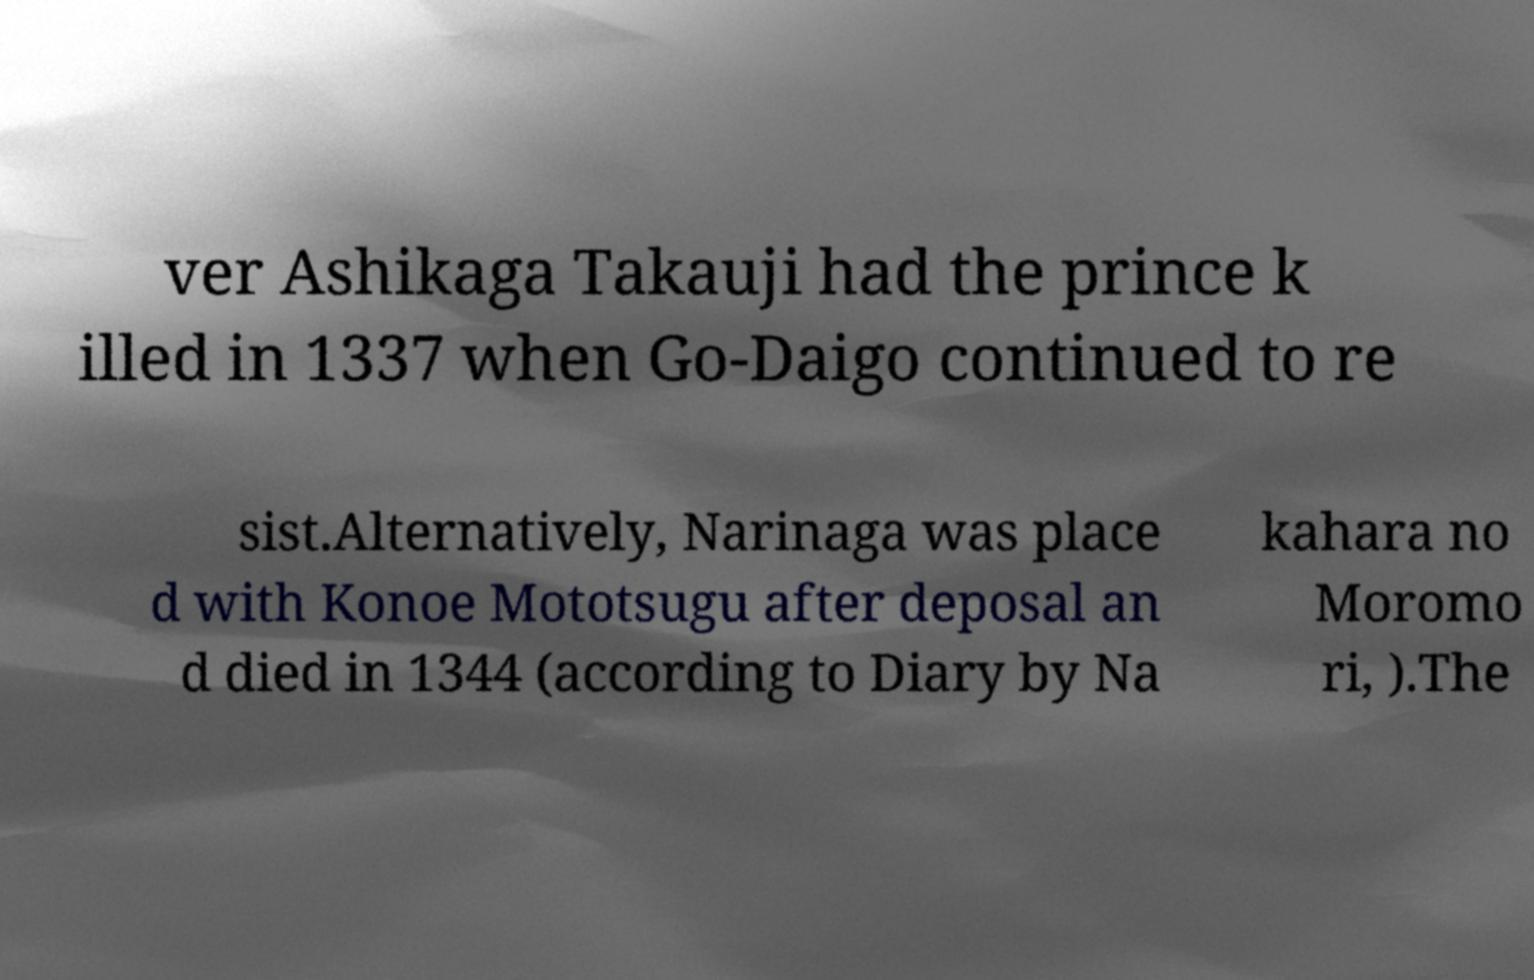Can you read and provide the text displayed in the image?This photo seems to have some interesting text. Can you extract and type it out for me? ver Ashikaga Takauji had the prince k illed in 1337 when Go-Daigo continued to re sist.Alternatively, Narinaga was place d with Konoe Mototsugu after deposal an d died in 1344 (according to Diary by Na kahara no Moromo ri, ).The 